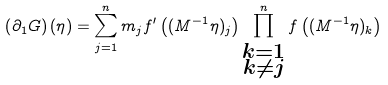<formula> <loc_0><loc_0><loc_500><loc_500>\left ( \partial _ { 1 } G \right ) ( \eta ) = \sum _ { j = 1 } ^ { n } m _ { j } f ^ { \prime } \left ( ( M ^ { - 1 } \eta ) _ { j } \right ) \prod _ { \substack { k = 1 \\ k \neq j } } ^ { n } f \left ( ( M ^ { - 1 } \eta ) _ { k } \right )</formula> 